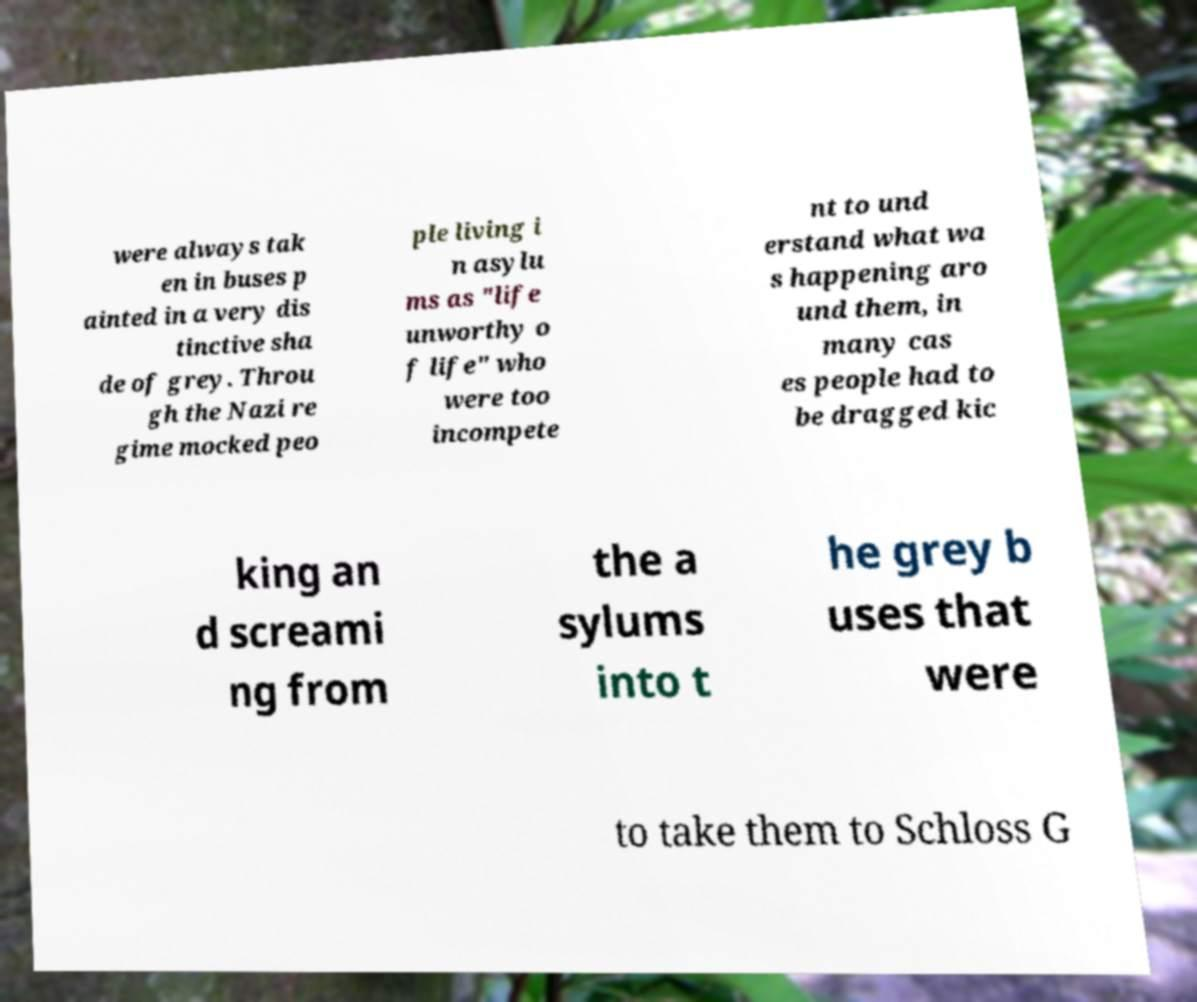Can you read and provide the text displayed in the image?This photo seems to have some interesting text. Can you extract and type it out for me? were always tak en in buses p ainted in a very dis tinctive sha de of grey. Throu gh the Nazi re gime mocked peo ple living i n asylu ms as "life unworthy o f life" who were too incompete nt to und erstand what wa s happening aro und them, in many cas es people had to be dragged kic king an d screami ng from the a sylums into t he grey b uses that were to take them to Schloss G 